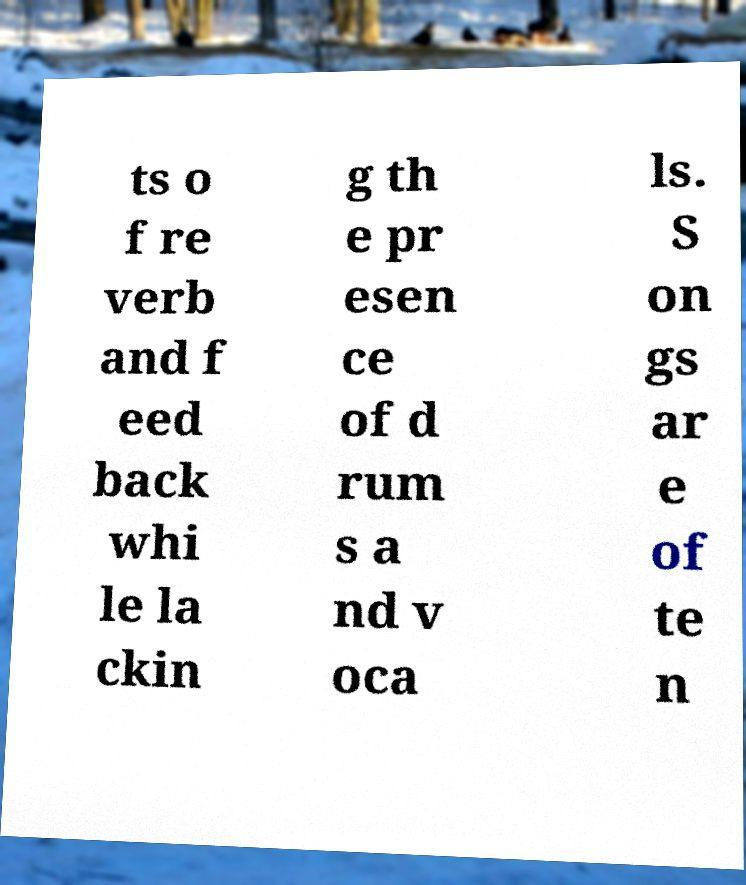There's text embedded in this image that I need extracted. Can you transcribe it verbatim? ts o f re verb and f eed back whi le la ckin g th e pr esen ce of d rum s a nd v oca ls. S on gs ar e of te n 